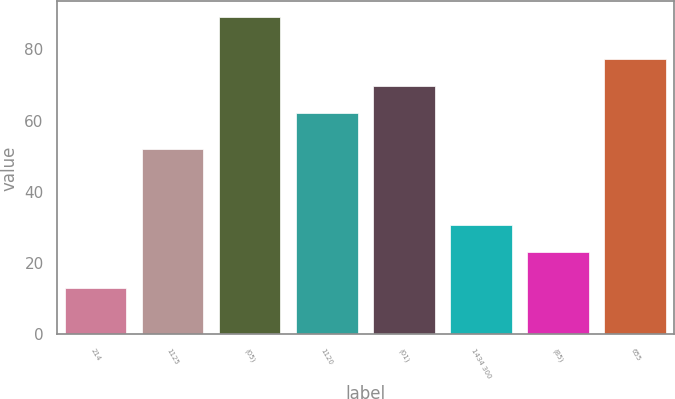<chart> <loc_0><loc_0><loc_500><loc_500><bar_chart><fcel>214<fcel>1125<fcel>(05)<fcel>1120<fcel>(01)<fcel>1434 300<fcel>(85)<fcel>655<nl><fcel>13<fcel>52<fcel>89<fcel>62<fcel>69.6<fcel>30.6<fcel>23<fcel>77.2<nl></chart> 